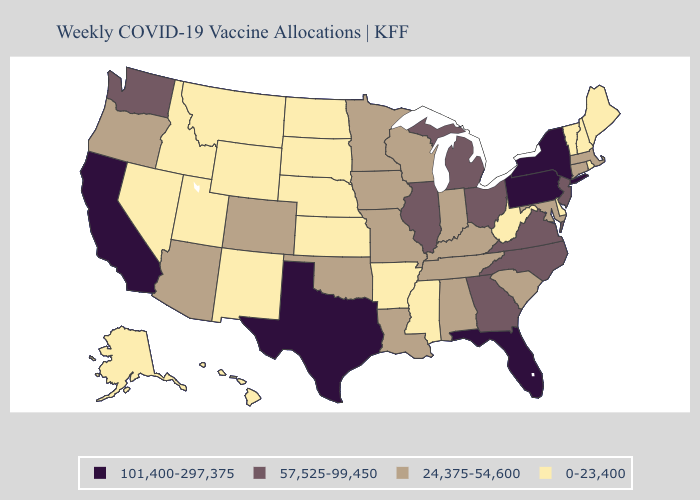Which states have the lowest value in the South?
Write a very short answer. Arkansas, Delaware, Mississippi, West Virginia. What is the value of Indiana?
Write a very short answer. 24,375-54,600. Which states have the highest value in the USA?
Concise answer only. California, Florida, New York, Pennsylvania, Texas. Does Oklahoma have a lower value than Florida?
Concise answer only. Yes. Among the states that border Georgia , does South Carolina have the highest value?
Keep it brief. No. Does the first symbol in the legend represent the smallest category?
Quick response, please. No. Does California have the highest value in the West?
Answer briefly. Yes. What is the lowest value in states that border Illinois?
Short answer required. 24,375-54,600. Does Michigan have a lower value than California?
Quick response, please. Yes. What is the value of West Virginia?
Concise answer only. 0-23,400. Does Missouri have the lowest value in the USA?
Short answer required. No. Name the states that have a value in the range 57,525-99,450?
Keep it brief. Georgia, Illinois, Michigan, New Jersey, North Carolina, Ohio, Virginia, Washington. Does Pennsylvania have the same value as New York?
Short answer required. Yes. Which states have the highest value in the USA?
Quick response, please. California, Florida, New York, Pennsylvania, Texas. Name the states that have a value in the range 101,400-297,375?
Short answer required. California, Florida, New York, Pennsylvania, Texas. 